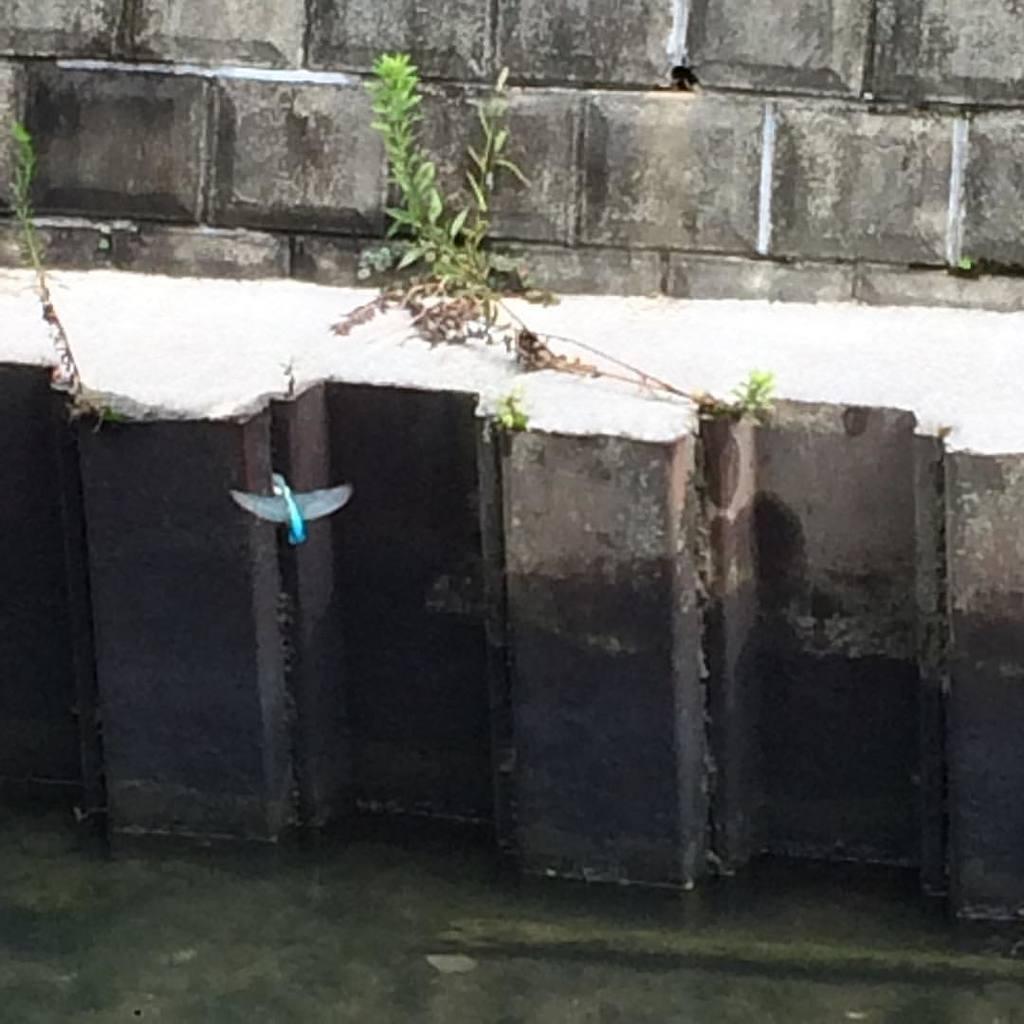Can you describe this image briefly? In this image I can see a blue colour thing and grass in the center. I can also see the wall in the background. 